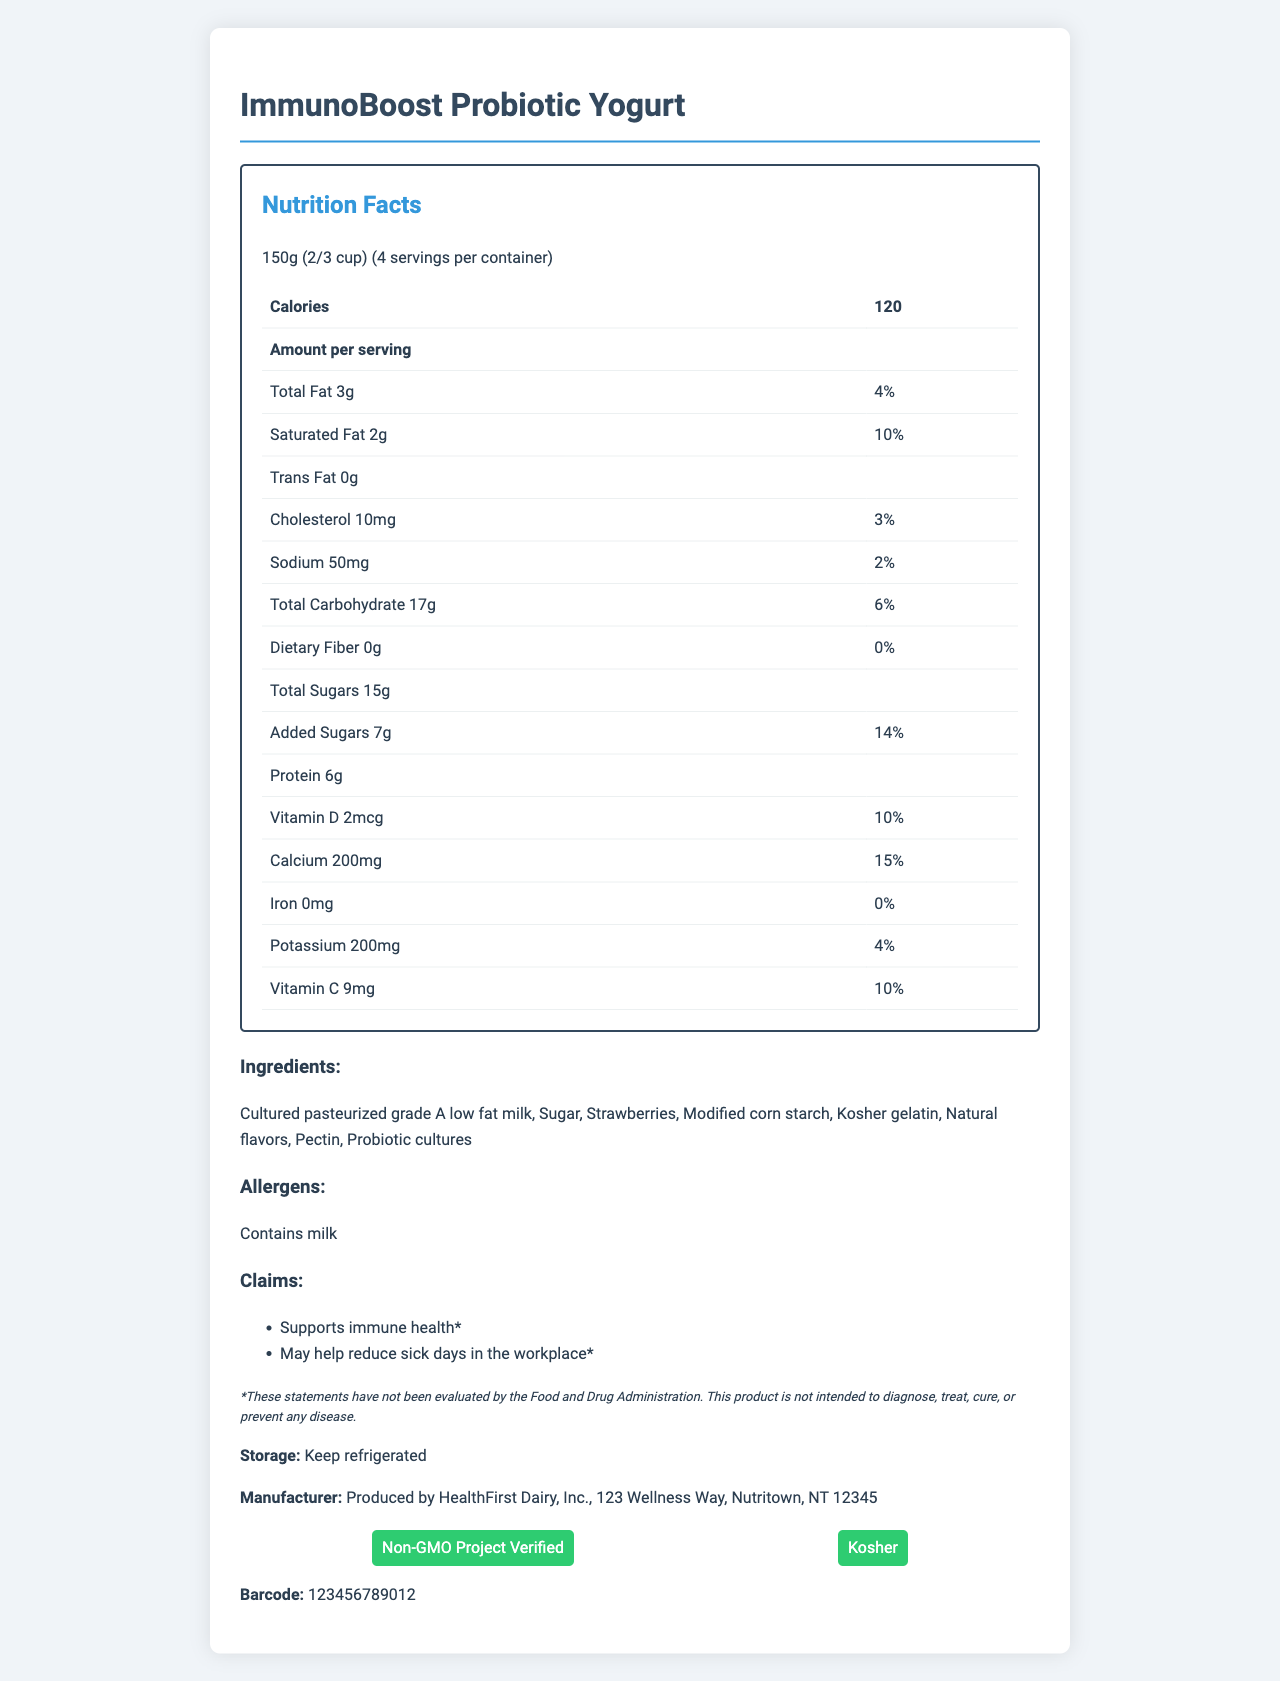what is the serving size for ImmunoBoost Probiotic Yogurt? The serving size is indicated at the top of the Nutrition Facts section.
Answer: 150g (2/3 cup) how many servings are there per container? The number of servings per container is listed in the Nutrition Facts section.
Answer: 4 how many calories are in one serving? The calories per serving are specified in bold within the Nutrition Facts table.
Answer: 120 what percentage of the daily value of calcium does one serving provide? The daily value percentage for calcium is listed next to the calcium amount in the Nutrition Facts.
Answer: 15% how many grams of total sugars are in one serving? The total sugars per serving are listed under the Total Carbohydrate section in the Nutrition Facts.
Answer: 15g does the yogurt contain iron? The iron amount is 0mg, resulting in 0% of the daily value, as per the Nutrition Facts.
Answer: No what are the main probiotic strains included in the yogurt? The probiotic strains are listed under the Probiotic Blend section of the document.
Answer: Lactobacillus acidophilus, Bifidobacterium lactis, Lactobacillus rhamnosus what is the storage instruction for this product? The storage instruction is listed before the manufacturer information.
Answer: Keep refrigerated is the product Non-GMO? The Non-GMO Project Verified certification is noted in the certifications section.
Answer: Yes does the yogurt have added sugars? The Nutrition Facts section shows Added Sugars as 7g, indicating it contains added sugars.
Answer: Yes what is the primary ingredient of the yogurt? The ingredients list starts with the primary ingredient.
Answer: Cultured pasteurized grade A low fat milk how much protein does one serving contain? The protein amount is listed in the Nutrition Facts section under the Calories sub-section.
Answer: 6g is the product labeled as Kosher? The certifications section includes "Kosher" as one of its certifications.
Answer: Yes which probiotic strain is not listed in the document? A. Lactobacillus acidophilus B. Bifidobacterium lactis C. Streptococcus thermophilus D. Lactobacillus rhamnosus The listed probiotic strains are Lactobacillus acidophilus, Bifidobacterium lactis, and Lactobacillus rhamnosus; Streptococcus thermophilus is not mentioned.
Answer: C what are the potential allergens in this product? A. Nuts B. Soy C. Milk D. Wheat The allergens section specifically mentions that the product contains milk.
Answer: C can this product treat or cure diseases? The disclaimer explicitly states that the product is not intended to diagnose, treat, cure, or prevent any disease.
Answer: No summarize the main information presented in the document. The document primarily focuses on offering complete insights into the yogurt’s nutritional value, ingredients, and health claims, with additional emphasis on certifications and disclaimers to ensure full transparency for consumers.
Answer: The document provides detailed nutritional information about ImmunoBoost Probiotic Yogurt, including serving size, calorie count, and nutrients, along with the ingredients, probiotic strains, and certifications. It also features health claims about immune support and reducing sick days, accompanied by a disclaimer about the non-evaluated statements. where is HealthFirst Dairy, Inc. located? The manufacturer information stating the location is given towards the end of the document.
Answer: 123 Wellness Way, Nutritown, NT 12345 how many probiotic cultures are included per serving? The amount of probiotic blend in CFU (colony-forming units) is listed at the bottom of the Nutrition Facts section.
Answer: 5 billion CFU can you determine the overall health benefits of consuming this yogurt regularly? The document does not provide enough information to determine the overall health benefits conclusively; it requires scientific studies or additional context.
Answer: I don't know 